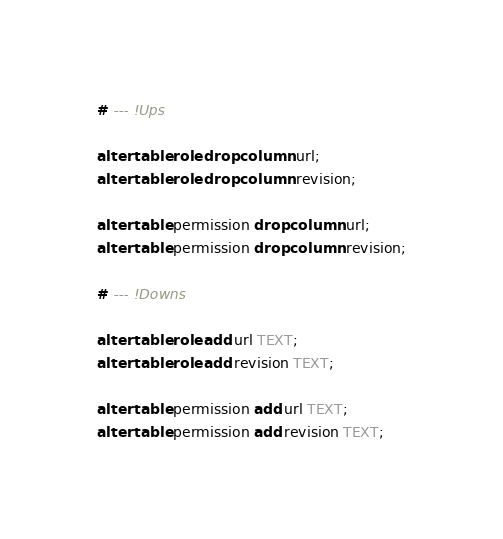<code> <loc_0><loc_0><loc_500><loc_500><_SQL_># --- !Ups

alter table role drop column url;
alter table role drop column revision;

alter table permission drop column url;
alter table permission drop column revision;

# --- !Downs

alter table role add url TEXT;
alter table role add revision TEXT;

alter table permission add url TEXT;
alter table permission add revision TEXT;

</code> 